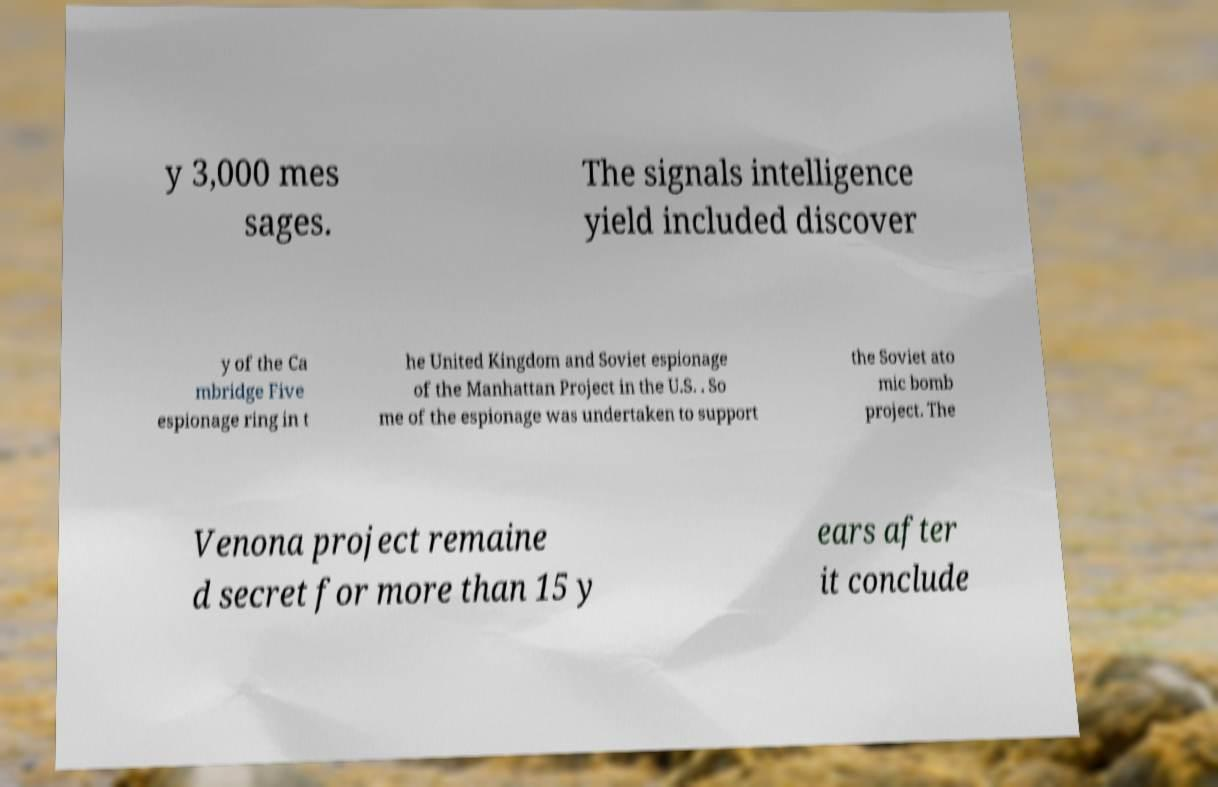Please read and relay the text visible in this image. What does it say? y 3,000 mes sages. The signals intelligence yield included discover y of the Ca mbridge Five espionage ring in t he United Kingdom and Soviet espionage of the Manhattan Project in the U.S. . So me of the espionage was undertaken to support the Soviet ato mic bomb project. The Venona project remaine d secret for more than 15 y ears after it conclude 